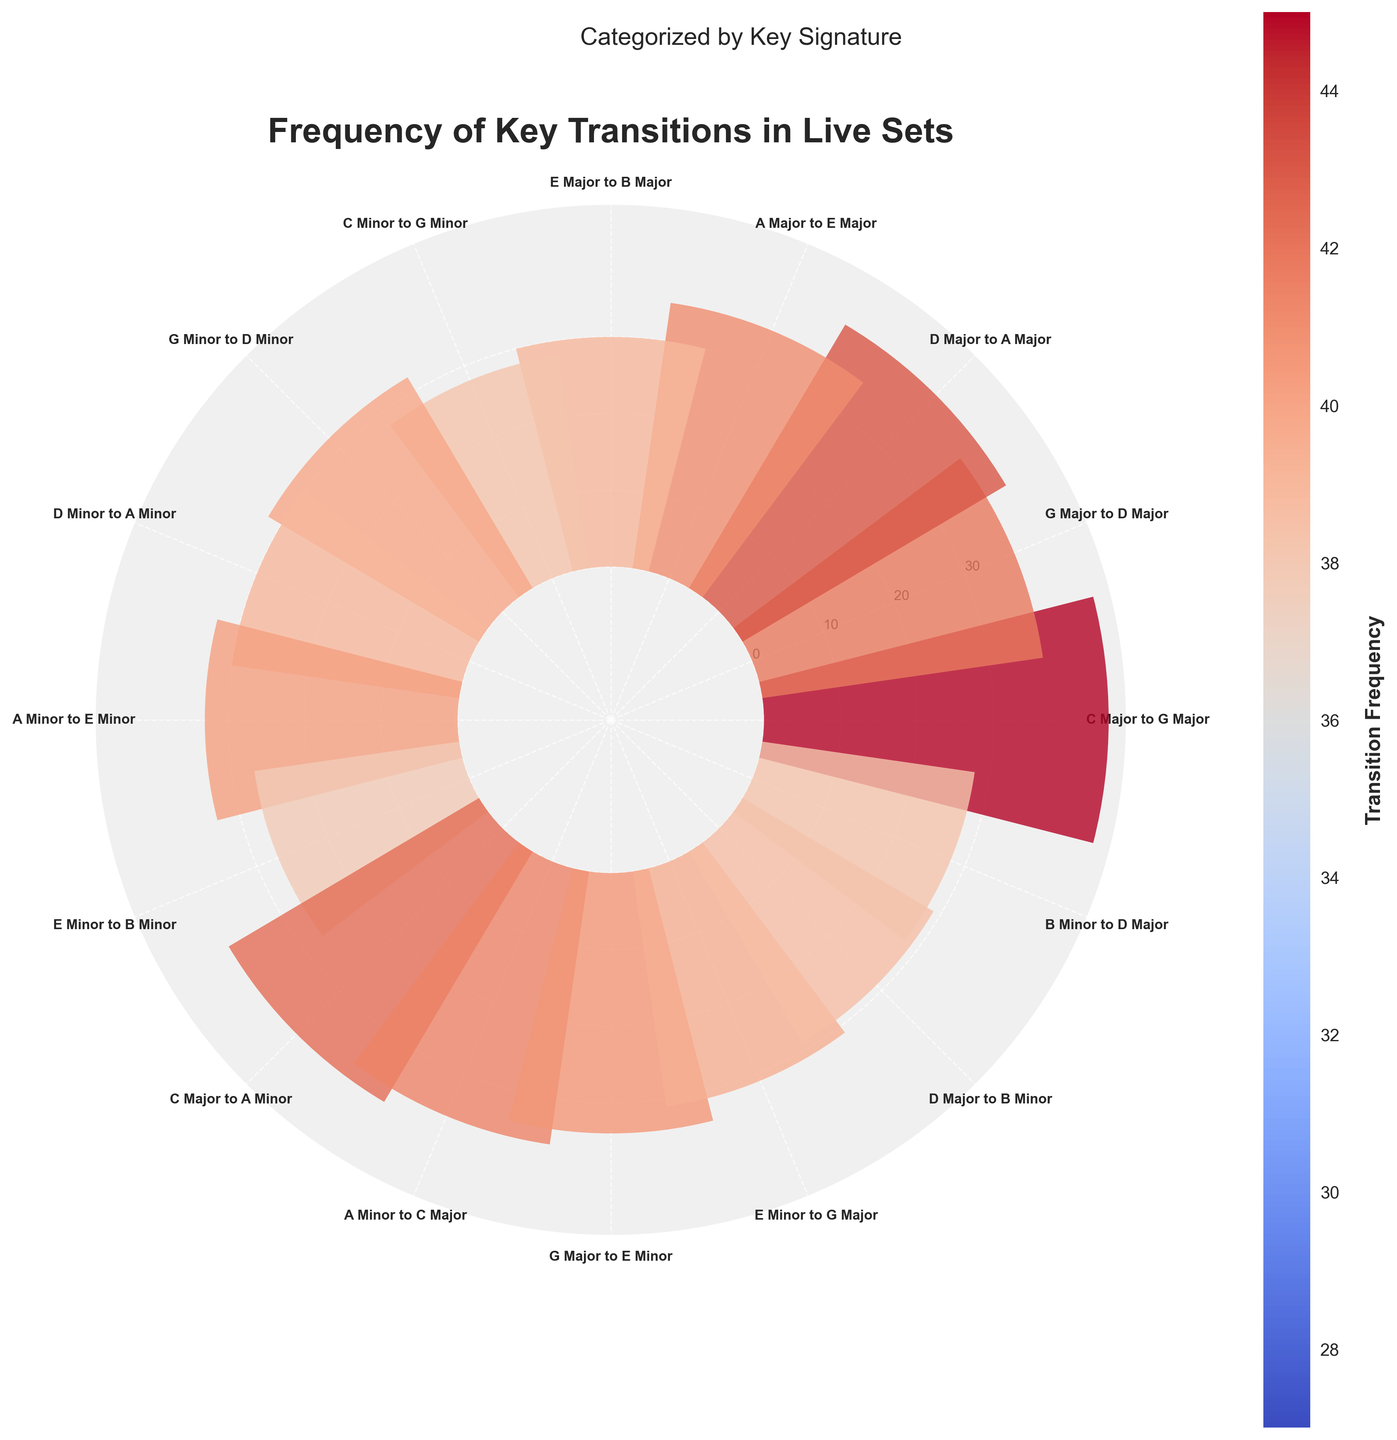What's the highest transition frequency recorded in the chart? The highest transition frequency can be determined by looking for the longest bar in the rose chart.
Answer: 45 Which key transition has the lowest frequency? The transition with the shortest bar in the rose chart represents the lowest frequency. The shortest bar corresponds to the frequency of 27.
Answer: E Minor to B Minor What is the average transition frequency of the major keys listed? To find the average transition frequency for the major keys, sum the frequencies and divide by the number of major key transitions: (45+37+40+35+30+38+36+34+31+29+28)/11 = 353/11.
Answer: 32.1 Between major and minor key transitions, which has a higher average frequency? Calculate separately for major and minor transitions. Major: (45+37+40+35+30+38+36+34+31+29+28)/11 = 32.1. Minor: (28+32+30+33+27)/5 = 30. Average for major transitions is higher.
Answer: Major Which two keys have nearly equal transition frequencies? Look for bars in the rose chart that are approximately the same length. For example, transition frequencies of A Minor to C Major and G Major to E Minor are 36 and 34 respectively.
Answer: A Minor to C Major and G Major to E Minor What are the transition frequencies between the key of C Major and other keys? Check all the bars labeled with transitions involving C Major. They are "C Major to G Major" (45) and "C Major to A Minor" (38).
Answer: 45 and 38 How many key transitions have a frequency between 30 and 40 inclusive? Count the number of bars whose lengths correspond to frequencies between 30 and 40. Transition frequencies are 37, 40, 35, 30, 32, 30, 33, 36, 34, 31, and 29.
Answer: 8 What's the total frequency of transitions involving minor keys? Sum the frequencies of all transitions involving minor keys: (28+32+30+33+27+38+36+34+31+29+28) = 346.
Answer: 346 How does the transition from C Major to G Major compare with the transition from E Major to B Major? Compare the lengths of the associated bars. The transition frequency from C Major to G Major (45) is higher than from E Major to B Major (30).
Answer: C Major to G Major is higher Which transition occurs more frequently: D Major to A Major or D Minor to A Minor? Compare the lengths of the associated bars. The transition frequency from D Major to A Major (40) is higher than from D Minor to A Minor (30).
Answer: D Major to A Major 